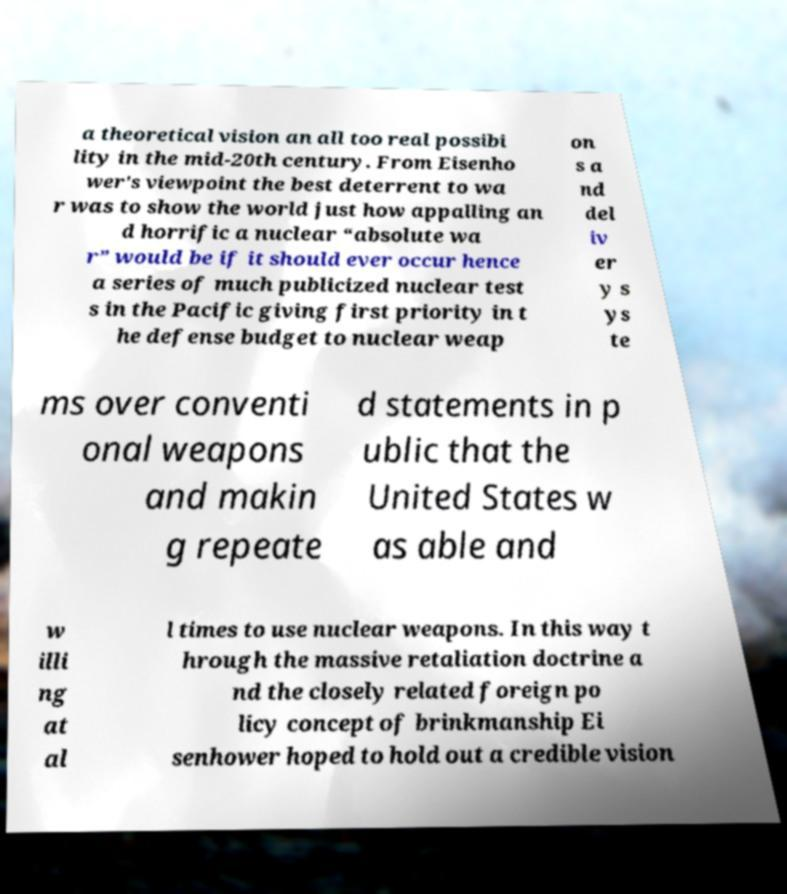For documentation purposes, I need the text within this image transcribed. Could you provide that? a theoretical vision an all too real possibi lity in the mid-20th century. From Eisenho wer's viewpoint the best deterrent to wa r was to show the world just how appalling an d horrific a nuclear “absolute wa r” would be if it should ever occur hence a series of much publicized nuclear test s in the Pacific giving first priority in t he defense budget to nuclear weap on s a nd del iv er y s ys te ms over conventi onal weapons and makin g repeate d statements in p ublic that the United States w as able and w illi ng at al l times to use nuclear weapons. In this way t hrough the massive retaliation doctrine a nd the closely related foreign po licy concept of brinkmanship Ei senhower hoped to hold out a credible vision 